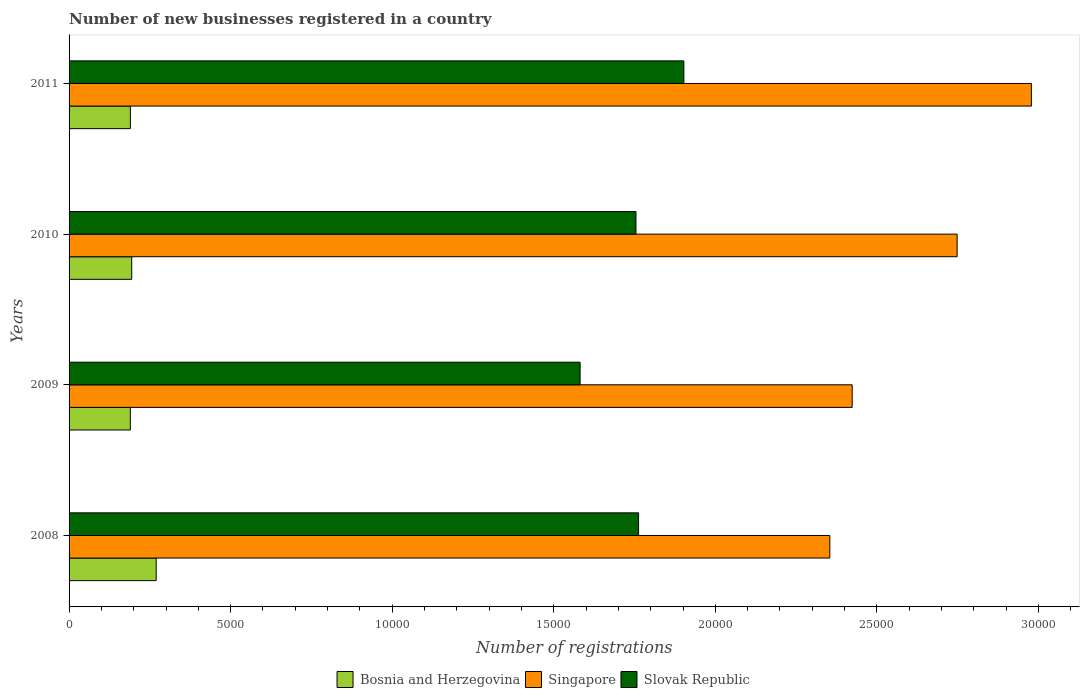How many different coloured bars are there?
Provide a short and direct response. 3. How many groups of bars are there?
Your answer should be very brief. 4. Are the number of bars per tick equal to the number of legend labels?
Ensure brevity in your answer.  Yes. Are the number of bars on each tick of the Y-axis equal?
Provide a short and direct response. Yes. How many bars are there on the 1st tick from the top?
Provide a succinct answer. 3. In how many cases, is the number of bars for a given year not equal to the number of legend labels?
Your answer should be compact. 0. What is the number of new businesses registered in Singapore in 2008?
Your response must be concise. 2.35e+04. Across all years, what is the maximum number of new businesses registered in Slovak Republic?
Offer a terse response. 1.90e+04. Across all years, what is the minimum number of new businesses registered in Singapore?
Keep it short and to the point. 2.35e+04. In which year was the number of new businesses registered in Singapore maximum?
Provide a short and direct response. 2011. In which year was the number of new businesses registered in Singapore minimum?
Provide a short and direct response. 2008. What is the total number of new businesses registered in Bosnia and Herzegovina in the graph?
Make the answer very short. 8428. What is the difference between the number of new businesses registered in Slovak Republic in 2009 and that in 2011?
Provide a short and direct response. -3211. What is the difference between the number of new businesses registered in Bosnia and Herzegovina in 2009 and the number of new businesses registered in Singapore in 2011?
Provide a succinct answer. -2.79e+04. What is the average number of new businesses registered in Bosnia and Herzegovina per year?
Offer a terse response. 2107. In the year 2008, what is the difference between the number of new businesses registered in Bosnia and Herzegovina and number of new businesses registered in Slovak Republic?
Give a very brief answer. -1.49e+04. In how many years, is the number of new businesses registered in Bosnia and Herzegovina greater than 16000 ?
Your answer should be very brief. 0. What is the ratio of the number of new businesses registered in Singapore in 2009 to that in 2010?
Provide a short and direct response. 0.88. Is the difference between the number of new businesses registered in Bosnia and Herzegovina in 2008 and 2011 greater than the difference between the number of new businesses registered in Slovak Republic in 2008 and 2011?
Your answer should be very brief. Yes. What is the difference between the highest and the second highest number of new businesses registered in Singapore?
Give a very brief answer. 2298. What is the difference between the highest and the lowest number of new businesses registered in Singapore?
Offer a very short reply. 6238. Is the sum of the number of new businesses registered in Slovak Republic in 2010 and 2011 greater than the maximum number of new businesses registered in Bosnia and Herzegovina across all years?
Make the answer very short. Yes. What does the 2nd bar from the top in 2009 represents?
Your answer should be compact. Singapore. What does the 2nd bar from the bottom in 2008 represents?
Your answer should be compact. Singapore. How many bars are there?
Ensure brevity in your answer.  12. How many years are there in the graph?
Offer a terse response. 4. Are the values on the major ticks of X-axis written in scientific E-notation?
Your response must be concise. No. What is the title of the graph?
Make the answer very short. Number of new businesses registered in a country. Does "Turkey" appear as one of the legend labels in the graph?
Make the answer very short. No. What is the label or title of the X-axis?
Provide a short and direct response. Number of registrations. What is the label or title of the Y-axis?
Ensure brevity in your answer.  Years. What is the Number of registrations in Bosnia and Herzegovina in 2008?
Give a very brief answer. 2696. What is the Number of registrations in Singapore in 2008?
Keep it short and to the point. 2.35e+04. What is the Number of registrations of Slovak Republic in 2008?
Keep it short and to the point. 1.76e+04. What is the Number of registrations of Bosnia and Herzegovina in 2009?
Keep it short and to the point. 1896. What is the Number of registrations of Singapore in 2009?
Provide a succinct answer. 2.42e+04. What is the Number of registrations of Slovak Republic in 2009?
Make the answer very short. 1.58e+04. What is the Number of registrations in Bosnia and Herzegovina in 2010?
Your response must be concise. 1939. What is the Number of registrations in Singapore in 2010?
Provide a succinct answer. 2.75e+04. What is the Number of registrations of Slovak Republic in 2010?
Offer a terse response. 1.75e+04. What is the Number of registrations in Bosnia and Herzegovina in 2011?
Provide a succinct answer. 1897. What is the Number of registrations in Singapore in 2011?
Give a very brief answer. 2.98e+04. What is the Number of registrations of Slovak Republic in 2011?
Make the answer very short. 1.90e+04. Across all years, what is the maximum Number of registrations of Bosnia and Herzegovina?
Offer a terse response. 2696. Across all years, what is the maximum Number of registrations of Singapore?
Keep it short and to the point. 2.98e+04. Across all years, what is the maximum Number of registrations in Slovak Republic?
Provide a succinct answer. 1.90e+04. Across all years, what is the minimum Number of registrations of Bosnia and Herzegovina?
Offer a very short reply. 1896. Across all years, what is the minimum Number of registrations of Singapore?
Offer a very short reply. 2.35e+04. Across all years, what is the minimum Number of registrations in Slovak Republic?
Offer a terse response. 1.58e+04. What is the total Number of registrations in Bosnia and Herzegovina in the graph?
Give a very brief answer. 8428. What is the total Number of registrations in Singapore in the graph?
Offer a very short reply. 1.05e+05. What is the total Number of registrations in Slovak Republic in the graph?
Your answer should be very brief. 7.00e+04. What is the difference between the Number of registrations of Bosnia and Herzegovina in 2008 and that in 2009?
Your response must be concise. 800. What is the difference between the Number of registrations of Singapore in 2008 and that in 2009?
Give a very brief answer. -692. What is the difference between the Number of registrations in Slovak Republic in 2008 and that in 2009?
Your answer should be very brief. 1810. What is the difference between the Number of registrations in Bosnia and Herzegovina in 2008 and that in 2010?
Your response must be concise. 757. What is the difference between the Number of registrations in Singapore in 2008 and that in 2010?
Make the answer very short. -3940. What is the difference between the Number of registrations of Bosnia and Herzegovina in 2008 and that in 2011?
Your answer should be very brief. 799. What is the difference between the Number of registrations in Singapore in 2008 and that in 2011?
Make the answer very short. -6238. What is the difference between the Number of registrations in Slovak Republic in 2008 and that in 2011?
Offer a terse response. -1401. What is the difference between the Number of registrations of Bosnia and Herzegovina in 2009 and that in 2010?
Offer a very short reply. -43. What is the difference between the Number of registrations of Singapore in 2009 and that in 2010?
Offer a very short reply. -3248. What is the difference between the Number of registrations of Slovak Republic in 2009 and that in 2010?
Provide a short and direct response. -1729. What is the difference between the Number of registrations of Bosnia and Herzegovina in 2009 and that in 2011?
Ensure brevity in your answer.  -1. What is the difference between the Number of registrations of Singapore in 2009 and that in 2011?
Keep it short and to the point. -5546. What is the difference between the Number of registrations of Slovak Republic in 2009 and that in 2011?
Keep it short and to the point. -3211. What is the difference between the Number of registrations in Singapore in 2010 and that in 2011?
Ensure brevity in your answer.  -2298. What is the difference between the Number of registrations in Slovak Republic in 2010 and that in 2011?
Your answer should be very brief. -1482. What is the difference between the Number of registrations in Bosnia and Herzegovina in 2008 and the Number of registrations in Singapore in 2009?
Offer a very short reply. -2.15e+04. What is the difference between the Number of registrations in Bosnia and Herzegovina in 2008 and the Number of registrations in Slovak Republic in 2009?
Ensure brevity in your answer.  -1.31e+04. What is the difference between the Number of registrations of Singapore in 2008 and the Number of registrations of Slovak Republic in 2009?
Your answer should be very brief. 7728. What is the difference between the Number of registrations in Bosnia and Herzegovina in 2008 and the Number of registrations in Singapore in 2010?
Ensure brevity in your answer.  -2.48e+04. What is the difference between the Number of registrations of Bosnia and Herzegovina in 2008 and the Number of registrations of Slovak Republic in 2010?
Provide a short and direct response. -1.48e+04. What is the difference between the Number of registrations in Singapore in 2008 and the Number of registrations in Slovak Republic in 2010?
Your answer should be very brief. 5999. What is the difference between the Number of registrations in Bosnia and Herzegovina in 2008 and the Number of registrations in Singapore in 2011?
Keep it short and to the point. -2.71e+04. What is the difference between the Number of registrations in Bosnia and Herzegovina in 2008 and the Number of registrations in Slovak Republic in 2011?
Your answer should be compact. -1.63e+04. What is the difference between the Number of registrations in Singapore in 2008 and the Number of registrations in Slovak Republic in 2011?
Provide a short and direct response. 4517. What is the difference between the Number of registrations in Bosnia and Herzegovina in 2009 and the Number of registrations in Singapore in 2010?
Give a very brief answer. -2.56e+04. What is the difference between the Number of registrations of Bosnia and Herzegovina in 2009 and the Number of registrations of Slovak Republic in 2010?
Provide a short and direct response. -1.56e+04. What is the difference between the Number of registrations in Singapore in 2009 and the Number of registrations in Slovak Republic in 2010?
Provide a succinct answer. 6691. What is the difference between the Number of registrations of Bosnia and Herzegovina in 2009 and the Number of registrations of Singapore in 2011?
Ensure brevity in your answer.  -2.79e+04. What is the difference between the Number of registrations in Bosnia and Herzegovina in 2009 and the Number of registrations in Slovak Republic in 2011?
Give a very brief answer. -1.71e+04. What is the difference between the Number of registrations in Singapore in 2009 and the Number of registrations in Slovak Republic in 2011?
Make the answer very short. 5209. What is the difference between the Number of registrations of Bosnia and Herzegovina in 2010 and the Number of registrations of Singapore in 2011?
Your answer should be compact. -2.78e+04. What is the difference between the Number of registrations in Bosnia and Herzegovina in 2010 and the Number of registrations in Slovak Republic in 2011?
Keep it short and to the point. -1.71e+04. What is the difference between the Number of registrations of Singapore in 2010 and the Number of registrations of Slovak Republic in 2011?
Your response must be concise. 8457. What is the average Number of registrations of Bosnia and Herzegovina per year?
Offer a terse response. 2107. What is the average Number of registrations in Singapore per year?
Your answer should be very brief. 2.63e+04. What is the average Number of registrations in Slovak Republic per year?
Make the answer very short. 1.75e+04. In the year 2008, what is the difference between the Number of registrations of Bosnia and Herzegovina and Number of registrations of Singapore?
Ensure brevity in your answer.  -2.08e+04. In the year 2008, what is the difference between the Number of registrations of Bosnia and Herzegovina and Number of registrations of Slovak Republic?
Provide a short and direct response. -1.49e+04. In the year 2008, what is the difference between the Number of registrations in Singapore and Number of registrations in Slovak Republic?
Your response must be concise. 5918. In the year 2009, what is the difference between the Number of registrations in Bosnia and Herzegovina and Number of registrations in Singapore?
Provide a succinct answer. -2.23e+04. In the year 2009, what is the difference between the Number of registrations of Bosnia and Herzegovina and Number of registrations of Slovak Republic?
Provide a succinct answer. -1.39e+04. In the year 2009, what is the difference between the Number of registrations of Singapore and Number of registrations of Slovak Republic?
Your response must be concise. 8420. In the year 2010, what is the difference between the Number of registrations of Bosnia and Herzegovina and Number of registrations of Singapore?
Keep it short and to the point. -2.55e+04. In the year 2010, what is the difference between the Number of registrations in Bosnia and Herzegovina and Number of registrations in Slovak Republic?
Make the answer very short. -1.56e+04. In the year 2010, what is the difference between the Number of registrations in Singapore and Number of registrations in Slovak Republic?
Your response must be concise. 9939. In the year 2011, what is the difference between the Number of registrations of Bosnia and Herzegovina and Number of registrations of Singapore?
Make the answer very short. -2.79e+04. In the year 2011, what is the difference between the Number of registrations of Bosnia and Herzegovina and Number of registrations of Slovak Republic?
Keep it short and to the point. -1.71e+04. In the year 2011, what is the difference between the Number of registrations of Singapore and Number of registrations of Slovak Republic?
Your response must be concise. 1.08e+04. What is the ratio of the Number of registrations in Bosnia and Herzegovina in 2008 to that in 2009?
Offer a terse response. 1.42. What is the ratio of the Number of registrations in Singapore in 2008 to that in 2009?
Offer a very short reply. 0.97. What is the ratio of the Number of registrations of Slovak Republic in 2008 to that in 2009?
Offer a very short reply. 1.11. What is the ratio of the Number of registrations in Bosnia and Herzegovina in 2008 to that in 2010?
Your answer should be compact. 1.39. What is the ratio of the Number of registrations in Singapore in 2008 to that in 2010?
Give a very brief answer. 0.86. What is the ratio of the Number of registrations in Bosnia and Herzegovina in 2008 to that in 2011?
Your response must be concise. 1.42. What is the ratio of the Number of registrations in Singapore in 2008 to that in 2011?
Your answer should be compact. 0.79. What is the ratio of the Number of registrations of Slovak Republic in 2008 to that in 2011?
Your answer should be very brief. 0.93. What is the ratio of the Number of registrations of Bosnia and Herzegovina in 2009 to that in 2010?
Your response must be concise. 0.98. What is the ratio of the Number of registrations of Singapore in 2009 to that in 2010?
Your answer should be very brief. 0.88. What is the ratio of the Number of registrations of Slovak Republic in 2009 to that in 2010?
Ensure brevity in your answer.  0.9. What is the ratio of the Number of registrations of Bosnia and Herzegovina in 2009 to that in 2011?
Make the answer very short. 1. What is the ratio of the Number of registrations of Singapore in 2009 to that in 2011?
Your response must be concise. 0.81. What is the ratio of the Number of registrations in Slovak Republic in 2009 to that in 2011?
Make the answer very short. 0.83. What is the ratio of the Number of registrations in Bosnia and Herzegovina in 2010 to that in 2011?
Offer a very short reply. 1.02. What is the ratio of the Number of registrations of Singapore in 2010 to that in 2011?
Offer a very short reply. 0.92. What is the ratio of the Number of registrations of Slovak Republic in 2010 to that in 2011?
Your answer should be compact. 0.92. What is the difference between the highest and the second highest Number of registrations in Bosnia and Herzegovina?
Offer a terse response. 757. What is the difference between the highest and the second highest Number of registrations of Singapore?
Your answer should be compact. 2298. What is the difference between the highest and the second highest Number of registrations in Slovak Republic?
Keep it short and to the point. 1401. What is the difference between the highest and the lowest Number of registrations of Bosnia and Herzegovina?
Keep it short and to the point. 800. What is the difference between the highest and the lowest Number of registrations of Singapore?
Provide a short and direct response. 6238. What is the difference between the highest and the lowest Number of registrations in Slovak Republic?
Provide a short and direct response. 3211. 